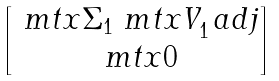<formula> <loc_0><loc_0><loc_500><loc_500>\begin{bmatrix} \ m t x { \Sigma } _ { 1 } \ m t x { V } _ { 1 } ^ { \ } a d j \\ \ m t x { 0 } \end{bmatrix}</formula> 